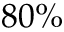Convert formula to latex. <formula><loc_0><loc_0><loc_500><loc_500>8 0 \%</formula> 